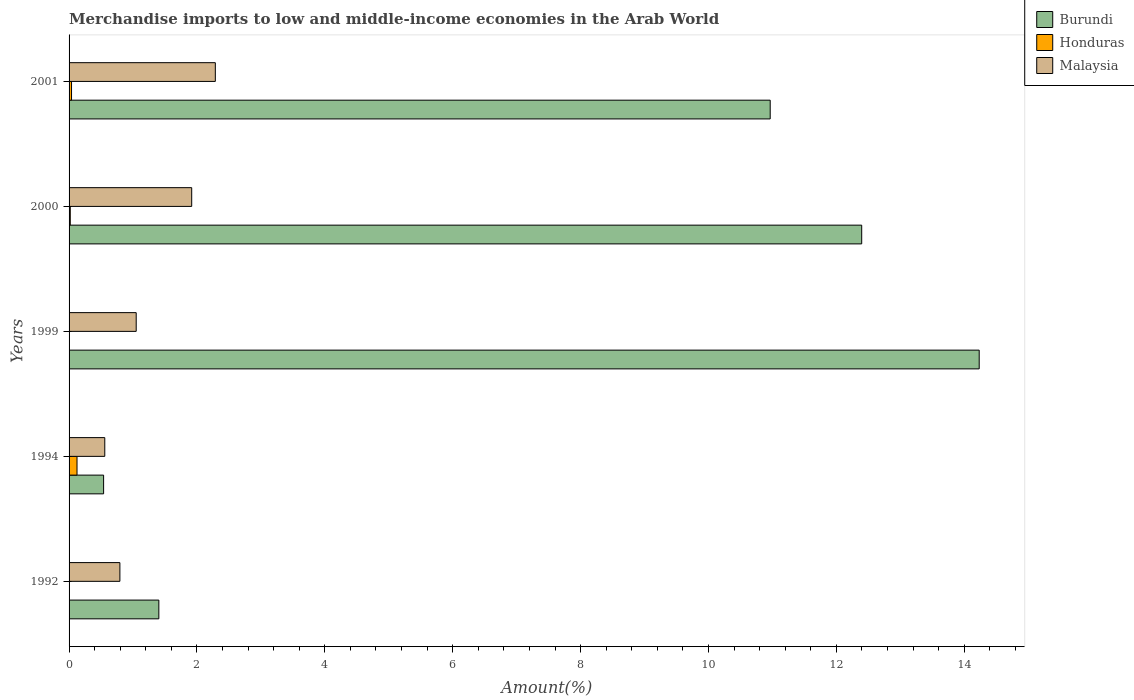Are the number of bars per tick equal to the number of legend labels?
Offer a very short reply. Yes. How many bars are there on the 1st tick from the top?
Offer a terse response. 3. What is the label of the 5th group of bars from the top?
Your answer should be very brief. 1992. In how many cases, is the number of bars for a given year not equal to the number of legend labels?
Offer a very short reply. 0. What is the percentage of amount earned from merchandise imports in Honduras in 2001?
Your answer should be very brief. 0.04. Across all years, what is the maximum percentage of amount earned from merchandise imports in Honduras?
Provide a succinct answer. 0.12. Across all years, what is the minimum percentage of amount earned from merchandise imports in Malaysia?
Your answer should be compact. 0.56. In which year was the percentage of amount earned from merchandise imports in Honduras minimum?
Make the answer very short. 1999. What is the total percentage of amount earned from merchandise imports in Honduras in the graph?
Offer a very short reply. 0.19. What is the difference between the percentage of amount earned from merchandise imports in Honduras in 1992 and that in 1994?
Offer a very short reply. -0.12. What is the difference between the percentage of amount earned from merchandise imports in Honduras in 1992 and the percentage of amount earned from merchandise imports in Malaysia in 1999?
Ensure brevity in your answer.  -1.04. What is the average percentage of amount earned from merchandise imports in Honduras per year?
Provide a succinct answer. 0.04. In the year 1992, what is the difference between the percentage of amount earned from merchandise imports in Burundi and percentage of amount earned from merchandise imports in Honduras?
Ensure brevity in your answer.  1.4. What is the ratio of the percentage of amount earned from merchandise imports in Burundi in 2000 to that in 2001?
Make the answer very short. 1.13. Is the difference between the percentage of amount earned from merchandise imports in Burundi in 1999 and 2000 greater than the difference between the percentage of amount earned from merchandise imports in Honduras in 1999 and 2000?
Your response must be concise. Yes. What is the difference between the highest and the second highest percentage of amount earned from merchandise imports in Malaysia?
Give a very brief answer. 0.37. What is the difference between the highest and the lowest percentage of amount earned from merchandise imports in Burundi?
Keep it short and to the point. 13.69. In how many years, is the percentage of amount earned from merchandise imports in Burundi greater than the average percentage of amount earned from merchandise imports in Burundi taken over all years?
Make the answer very short. 3. What does the 3rd bar from the top in 1994 represents?
Provide a short and direct response. Burundi. What does the 1st bar from the bottom in 1994 represents?
Provide a short and direct response. Burundi. How many bars are there?
Make the answer very short. 15. Are all the bars in the graph horizontal?
Make the answer very short. Yes. How many years are there in the graph?
Provide a short and direct response. 5. How many legend labels are there?
Ensure brevity in your answer.  3. How are the legend labels stacked?
Offer a very short reply. Vertical. What is the title of the graph?
Your response must be concise. Merchandise imports to low and middle-income economies in the Arab World. Does "Low & middle income" appear as one of the legend labels in the graph?
Offer a very short reply. No. What is the label or title of the X-axis?
Offer a very short reply. Amount(%). What is the label or title of the Y-axis?
Provide a succinct answer. Years. What is the Amount(%) of Burundi in 1992?
Provide a short and direct response. 1.4. What is the Amount(%) of Honduras in 1992?
Provide a succinct answer. 0.01. What is the Amount(%) in Malaysia in 1992?
Your answer should be compact. 0.79. What is the Amount(%) of Burundi in 1994?
Provide a short and direct response. 0.54. What is the Amount(%) of Honduras in 1994?
Your answer should be very brief. 0.12. What is the Amount(%) of Malaysia in 1994?
Provide a short and direct response. 0.56. What is the Amount(%) in Burundi in 1999?
Provide a short and direct response. 14.23. What is the Amount(%) in Honduras in 1999?
Offer a very short reply. 0. What is the Amount(%) of Malaysia in 1999?
Your answer should be compact. 1.05. What is the Amount(%) of Burundi in 2000?
Your answer should be very brief. 12.4. What is the Amount(%) in Honduras in 2000?
Provide a succinct answer. 0.02. What is the Amount(%) of Malaysia in 2000?
Provide a succinct answer. 1.92. What is the Amount(%) of Burundi in 2001?
Offer a very short reply. 10.97. What is the Amount(%) of Honduras in 2001?
Offer a very short reply. 0.04. What is the Amount(%) of Malaysia in 2001?
Give a very brief answer. 2.29. Across all years, what is the maximum Amount(%) of Burundi?
Your answer should be very brief. 14.23. Across all years, what is the maximum Amount(%) of Honduras?
Provide a succinct answer. 0.12. Across all years, what is the maximum Amount(%) of Malaysia?
Offer a very short reply. 2.29. Across all years, what is the minimum Amount(%) of Burundi?
Keep it short and to the point. 0.54. Across all years, what is the minimum Amount(%) in Honduras?
Keep it short and to the point. 0. Across all years, what is the minimum Amount(%) in Malaysia?
Your answer should be compact. 0.56. What is the total Amount(%) in Burundi in the graph?
Provide a succinct answer. 39.54. What is the total Amount(%) of Honduras in the graph?
Give a very brief answer. 0.19. What is the total Amount(%) of Malaysia in the graph?
Give a very brief answer. 6.61. What is the difference between the Amount(%) of Burundi in 1992 and that in 1994?
Keep it short and to the point. 0.86. What is the difference between the Amount(%) of Honduras in 1992 and that in 1994?
Offer a very short reply. -0.12. What is the difference between the Amount(%) of Malaysia in 1992 and that in 1994?
Your response must be concise. 0.24. What is the difference between the Amount(%) in Burundi in 1992 and that in 1999?
Give a very brief answer. -12.83. What is the difference between the Amount(%) of Honduras in 1992 and that in 1999?
Give a very brief answer. 0. What is the difference between the Amount(%) in Malaysia in 1992 and that in 1999?
Make the answer very short. -0.26. What is the difference between the Amount(%) of Burundi in 1992 and that in 2000?
Give a very brief answer. -10.99. What is the difference between the Amount(%) in Honduras in 1992 and that in 2000?
Your answer should be compact. -0.01. What is the difference between the Amount(%) in Malaysia in 1992 and that in 2000?
Provide a succinct answer. -1.12. What is the difference between the Amount(%) of Burundi in 1992 and that in 2001?
Ensure brevity in your answer.  -9.56. What is the difference between the Amount(%) of Honduras in 1992 and that in 2001?
Make the answer very short. -0.03. What is the difference between the Amount(%) of Malaysia in 1992 and that in 2001?
Your answer should be very brief. -1.49. What is the difference between the Amount(%) in Burundi in 1994 and that in 1999?
Make the answer very short. -13.69. What is the difference between the Amount(%) in Honduras in 1994 and that in 1999?
Make the answer very short. 0.12. What is the difference between the Amount(%) in Malaysia in 1994 and that in 1999?
Provide a succinct answer. -0.49. What is the difference between the Amount(%) in Burundi in 1994 and that in 2000?
Offer a very short reply. -11.86. What is the difference between the Amount(%) of Honduras in 1994 and that in 2000?
Keep it short and to the point. 0.11. What is the difference between the Amount(%) of Malaysia in 1994 and that in 2000?
Your answer should be very brief. -1.36. What is the difference between the Amount(%) in Burundi in 1994 and that in 2001?
Your answer should be very brief. -10.43. What is the difference between the Amount(%) in Honduras in 1994 and that in 2001?
Your answer should be very brief. 0.09. What is the difference between the Amount(%) in Malaysia in 1994 and that in 2001?
Your response must be concise. -1.73. What is the difference between the Amount(%) of Burundi in 1999 and that in 2000?
Provide a succinct answer. 1.84. What is the difference between the Amount(%) of Honduras in 1999 and that in 2000?
Offer a terse response. -0.02. What is the difference between the Amount(%) in Malaysia in 1999 and that in 2000?
Offer a very short reply. -0.87. What is the difference between the Amount(%) in Burundi in 1999 and that in 2001?
Offer a terse response. 3.27. What is the difference between the Amount(%) in Honduras in 1999 and that in 2001?
Provide a succinct answer. -0.04. What is the difference between the Amount(%) in Malaysia in 1999 and that in 2001?
Provide a succinct answer. -1.24. What is the difference between the Amount(%) of Burundi in 2000 and that in 2001?
Provide a succinct answer. 1.43. What is the difference between the Amount(%) in Honduras in 2000 and that in 2001?
Offer a terse response. -0.02. What is the difference between the Amount(%) of Malaysia in 2000 and that in 2001?
Your response must be concise. -0.37. What is the difference between the Amount(%) of Burundi in 1992 and the Amount(%) of Honduras in 1994?
Ensure brevity in your answer.  1.28. What is the difference between the Amount(%) in Burundi in 1992 and the Amount(%) in Malaysia in 1994?
Your answer should be compact. 0.85. What is the difference between the Amount(%) of Honduras in 1992 and the Amount(%) of Malaysia in 1994?
Your answer should be compact. -0.55. What is the difference between the Amount(%) in Burundi in 1992 and the Amount(%) in Honduras in 1999?
Ensure brevity in your answer.  1.4. What is the difference between the Amount(%) in Burundi in 1992 and the Amount(%) in Malaysia in 1999?
Ensure brevity in your answer.  0.35. What is the difference between the Amount(%) in Honduras in 1992 and the Amount(%) in Malaysia in 1999?
Give a very brief answer. -1.04. What is the difference between the Amount(%) in Burundi in 1992 and the Amount(%) in Honduras in 2000?
Offer a terse response. 1.39. What is the difference between the Amount(%) of Burundi in 1992 and the Amount(%) of Malaysia in 2000?
Keep it short and to the point. -0.51. What is the difference between the Amount(%) of Honduras in 1992 and the Amount(%) of Malaysia in 2000?
Make the answer very short. -1.91. What is the difference between the Amount(%) in Burundi in 1992 and the Amount(%) in Honduras in 2001?
Your response must be concise. 1.37. What is the difference between the Amount(%) in Burundi in 1992 and the Amount(%) in Malaysia in 2001?
Ensure brevity in your answer.  -0.88. What is the difference between the Amount(%) in Honduras in 1992 and the Amount(%) in Malaysia in 2001?
Your answer should be very brief. -2.28. What is the difference between the Amount(%) of Burundi in 1994 and the Amount(%) of Honduras in 1999?
Your answer should be compact. 0.54. What is the difference between the Amount(%) in Burundi in 1994 and the Amount(%) in Malaysia in 1999?
Provide a short and direct response. -0.51. What is the difference between the Amount(%) of Honduras in 1994 and the Amount(%) of Malaysia in 1999?
Your answer should be very brief. -0.93. What is the difference between the Amount(%) in Burundi in 1994 and the Amount(%) in Honduras in 2000?
Offer a very short reply. 0.52. What is the difference between the Amount(%) of Burundi in 1994 and the Amount(%) of Malaysia in 2000?
Keep it short and to the point. -1.38. What is the difference between the Amount(%) in Honduras in 1994 and the Amount(%) in Malaysia in 2000?
Keep it short and to the point. -1.79. What is the difference between the Amount(%) in Burundi in 1994 and the Amount(%) in Honduras in 2001?
Offer a very short reply. 0.5. What is the difference between the Amount(%) of Burundi in 1994 and the Amount(%) of Malaysia in 2001?
Make the answer very short. -1.75. What is the difference between the Amount(%) of Honduras in 1994 and the Amount(%) of Malaysia in 2001?
Your response must be concise. -2.16. What is the difference between the Amount(%) in Burundi in 1999 and the Amount(%) in Honduras in 2000?
Keep it short and to the point. 14.22. What is the difference between the Amount(%) of Burundi in 1999 and the Amount(%) of Malaysia in 2000?
Make the answer very short. 12.32. What is the difference between the Amount(%) of Honduras in 1999 and the Amount(%) of Malaysia in 2000?
Offer a terse response. -1.92. What is the difference between the Amount(%) of Burundi in 1999 and the Amount(%) of Honduras in 2001?
Ensure brevity in your answer.  14.2. What is the difference between the Amount(%) in Burundi in 1999 and the Amount(%) in Malaysia in 2001?
Your answer should be very brief. 11.95. What is the difference between the Amount(%) in Honduras in 1999 and the Amount(%) in Malaysia in 2001?
Your response must be concise. -2.29. What is the difference between the Amount(%) of Burundi in 2000 and the Amount(%) of Honduras in 2001?
Give a very brief answer. 12.36. What is the difference between the Amount(%) of Burundi in 2000 and the Amount(%) of Malaysia in 2001?
Your answer should be very brief. 10.11. What is the difference between the Amount(%) in Honduras in 2000 and the Amount(%) in Malaysia in 2001?
Provide a succinct answer. -2.27. What is the average Amount(%) in Burundi per year?
Your response must be concise. 7.91. What is the average Amount(%) in Honduras per year?
Your answer should be very brief. 0.04. What is the average Amount(%) in Malaysia per year?
Offer a terse response. 1.32. In the year 1992, what is the difference between the Amount(%) of Burundi and Amount(%) of Honduras?
Offer a very short reply. 1.4. In the year 1992, what is the difference between the Amount(%) in Burundi and Amount(%) in Malaysia?
Offer a terse response. 0.61. In the year 1992, what is the difference between the Amount(%) of Honduras and Amount(%) of Malaysia?
Your answer should be compact. -0.79. In the year 1994, what is the difference between the Amount(%) in Burundi and Amount(%) in Honduras?
Your response must be concise. 0.42. In the year 1994, what is the difference between the Amount(%) in Burundi and Amount(%) in Malaysia?
Provide a short and direct response. -0.02. In the year 1994, what is the difference between the Amount(%) in Honduras and Amount(%) in Malaysia?
Ensure brevity in your answer.  -0.43. In the year 1999, what is the difference between the Amount(%) of Burundi and Amount(%) of Honduras?
Your answer should be compact. 14.23. In the year 1999, what is the difference between the Amount(%) of Burundi and Amount(%) of Malaysia?
Give a very brief answer. 13.18. In the year 1999, what is the difference between the Amount(%) in Honduras and Amount(%) in Malaysia?
Offer a very short reply. -1.05. In the year 2000, what is the difference between the Amount(%) in Burundi and Amount(%) in Honduras?
Provide a short and direct response. 12.38. In the year 2000, what is the difference between the Amount(%) in Burundi and Amount(%) in Malaysia?
Make the answer very short. 10.48. In the year 2000, what is the difference between the Amount(%) in Honduras and Amount(%) in Malaysia?
Ensure brevity in your answer.  -1.9. In the year 2001, what is the difference between the Amount(%) in Burundi and Amount(%) in Honduras?
Offer a very short reply. 10.93. In the year 2001, what is the difference between the Amount(%) of Burundi and Amount(%) of Malaysia?
Your answer should be very brief. 8.68. In the year 2001, what is the difference between the Amount(%) in Honduras and Amount(%) in Malaysia?
Offer a very short reply. -2.25. What is the ratio of the Amount(%) in Burundi in 1992 to that in 1994?
Keep it short and to the point. 2.6. What is the ratio of the Amount(%) in Honduras in 1992 to that in 1994?
Make the answer very short. 0.04. What is the ratio of the Amount(%) in Malaysia in 1992 to that in 1994?
Provide a succinct answer. 1.42. What is the ratio of the Amount(%) in Burundi in 1992 to that in 1999?
Provide a short and direct response. 0.1. What is the ratio of the Amount(%) of Honduras in 1992 to that in 1999?
Ensure brevity in your answer.  8.41. What is the ratio of the Amount(%) in Malaysia in 1992 to that in 1999?
Ensure brevity in your answer.  0.76. What is the ratio of the Amount(%) of Burundi in 1992 to that in 2000?
Make the answer very short. 0.11. What is the ratio of the Amount(%) of Honduras in 1992 to that in 2000?
Give a very brief answer. 0.29. What is the ratio of the Amount(%) in Malaysia in 1992 to that in 2000?
Your answer should be very brief. 0.41. What is the ratio of the Amount(%) in Burundi in 1992 to that in 2001?
Offer a very short reply. 0.13. What is the ratio of the Amount(%) of Honduras in 1992 to that in 2001?
Ensure brevity in your answer.  0.14. What is the ratio of the Amount(%) in Malaysia in 1992 to that in 2001?
Offer a terse response. 0.35. What is the ratio of the Amount(%) in Burundi in 1994 to that in 1999?
Your answer should be very brief. 0.04. What is the ratio of the Amount(%) of Honduras in 1994 to that in 1999?
Make the answer very short. 189.38. What is the ratio of the Amount(%) of Malaysia in 1994 to that in 1999?
Your response must be concise. 0.53. What is the ratio of the Amount(%) in Burundi in 1994 to that in 2000?
Your answer should be compact. 0.04. What is the ratio of the Amount(%) in Honduras in 1994 to that in 2000?
Give a very brief answer. 6.62. What is the ratio of the Amount(%) of Malaysia in 1994 to that in 2000?
Provide a short and direct response. 0.29. What is the ratio of the Amount(%) of Burundi in 1994 to that in 2001?
Give a very brief answer. 0.05. What is the ratio of the Amount(%) of Honduras in 1994 to that in 2001?
Keep it short and to the point. 3.23. What is the ratio of the Amount(%) in Malaysia in 1994 to that in 2001?
Ensure brevity in your answer.  0.24. What is the ratio of the Amount(%) of Burundi in 1999 to that in 2000?
Ensure brevity in your answer.  1.15. What is the ratio of the Amount(%) of Honduras in 1999 to that in 2000?
Keep it short and to the point. 0.04. What is the ratio of the Amount(%) in Malaysia in 1999 to that in 2000?
Your answer should be very brief. 0.55. What is the ratio of the Amount(%) in Burundi in 1999 to that in 2001?
Your answer should be very brief. 1.3. What is the ratio of the Amount(%) of Honduras in 1999 to that in 2001?
Your response must be concise. 0.02. What is the ratio of the Amount(%) of Malaysia in 1999 to that in 2001?
Your answer should be compact. 0.46. What is the ratio of the Amount(%) of Burundi in 2000 to that in 2001?
Provide a short and direct response. 1.13. What is the ratio of the Amount(%) in Honduras in 2000 to that in 2001?
Provide a short and direct response. 0.49. What is the ratio of the Amount(%) of Malaysia in 2000 to that in 2001?
Keep it short and to the point. 0.84. What is the difference between the highest and the second highest Amount(%) in Burundi?
Provide a succinct answer. 1.84. What is the difference between the highest and the second highest Amount(%) in Honduras?
Offer a terse response. 0.09. What is the difference between the highest and the second highest Amount(%) in Malaysia?
Your answer should be very brief. 0.37. What is the difference between the highest and the lowest Amount(%) of Burundi?
Provide a succinct answer. 13.69. What is the difference between the highest and the lowest Amount(%) in Honduras?
Your response must be concise. 0.12. What is the difference between the highest and the lowest Amount(%) in Malaysia?
Make the answer very short. 1.73. 